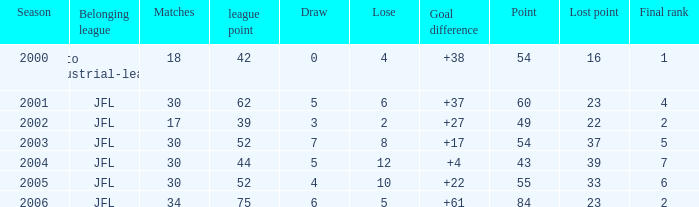Tell me the highest matches for point 43 and final rank less than 7 None. 